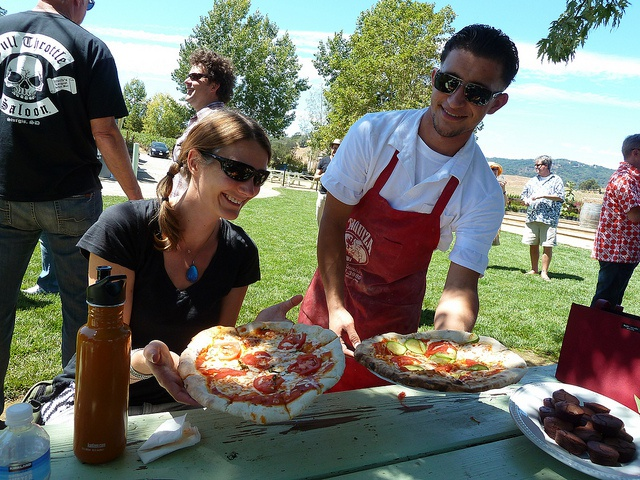Describe the objects in this image and their specific colors. I can see dining table in lightblue, teal, black, and gray tones, people in lightblue, maroon, black, gray, and darkgray tones, people in lightblue, black, white, darkgray, and gray tones, people in lightblue, black, maroon, and gray tones, and pizza in lightblue, gray, maroon, and ivory tones in this image. 